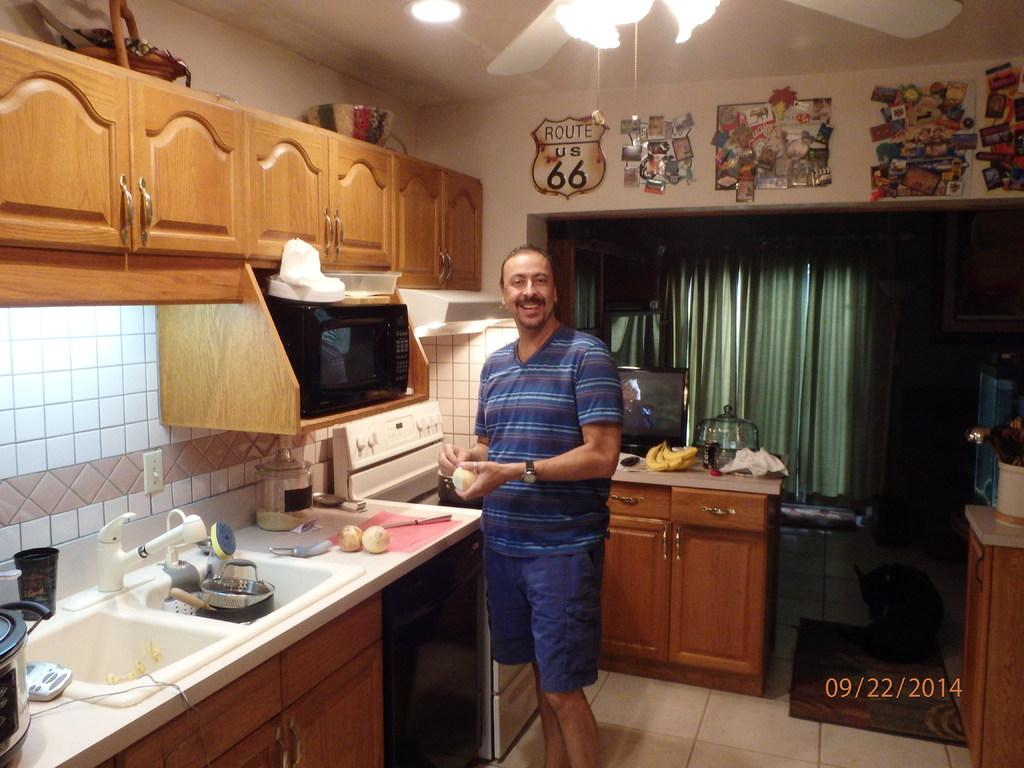<image>
Offer a succinct explanation of the picture presented. On September 22nd 2014 a man cuts onions in a kitchen. 